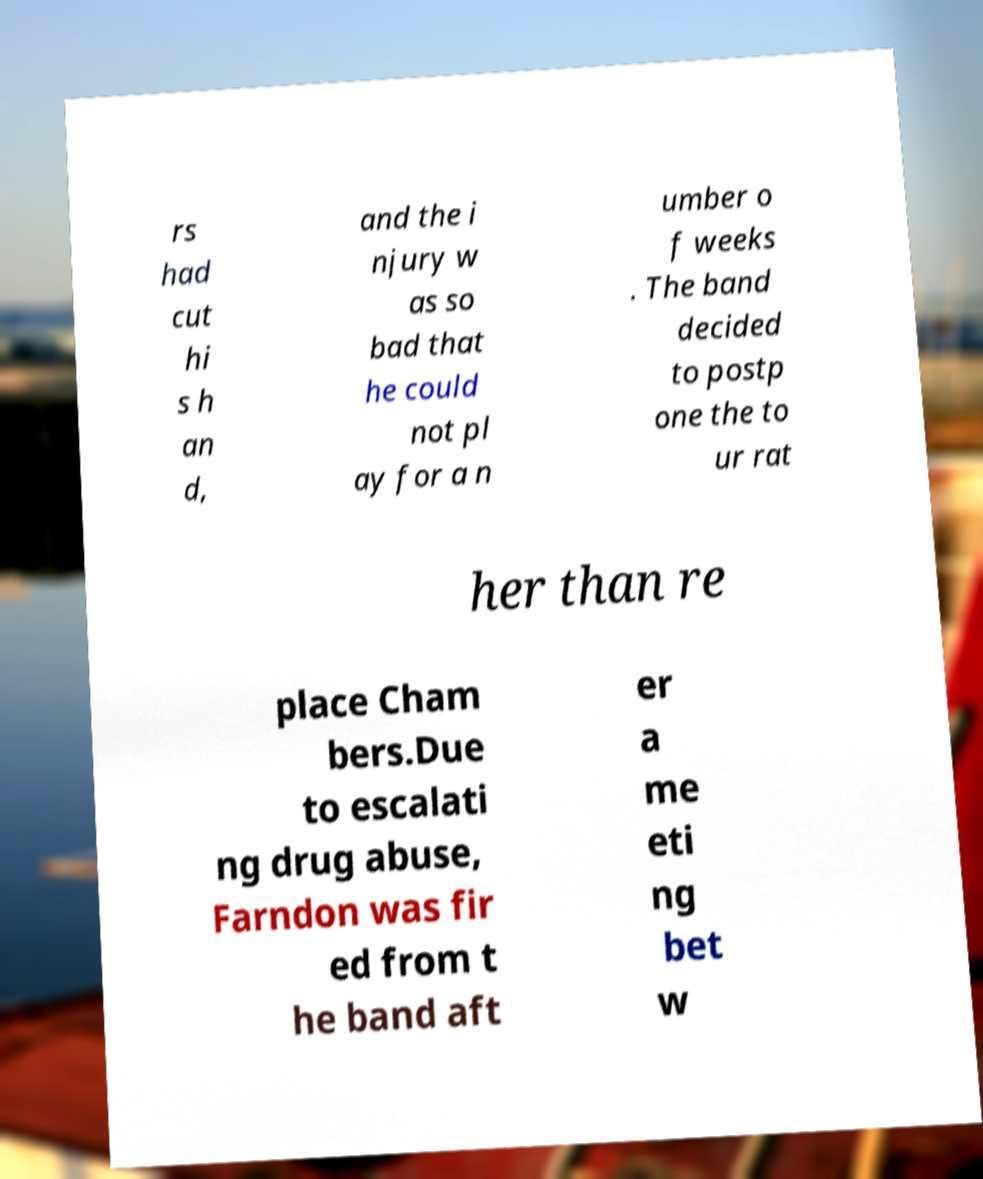I need the written content from this picture converted into text. Can you do that? rs had cut hi s h an d, and the i njury w as so bad that he could not pl ay for a n umber o f weeks . The band decided to postp one the to ur rat her than re place Cham bers.Due to escalati ng drug abuse, Farndon was fir ed from t he band aft er a me eti ng bet w 